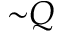<formula> <loc_0><loc_0><loc_500><loc_500>{ \sim } Q</formula> 